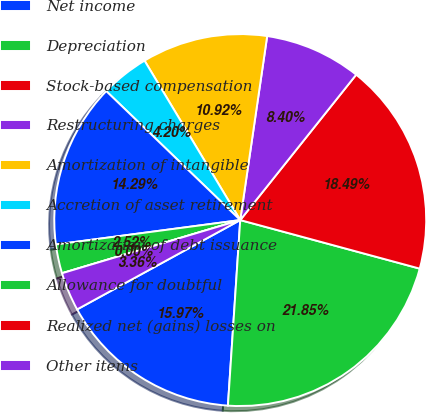<chart> <loc_0><loc_0><loc_500><loc_500><pie_chart><fcel>Net income<fcel>Depreciation<fcel>Stock-based compensation<fcel>Restructuring charges<fcel>Amortization of intangible<fcel>Accretion of asset retirement<fcel>Amortization of debt issuance<fcel>Allowance for doubtful<fcel>Realized net (gains) losses on<fcel>Other items<nl><fcel>15.97%<fcel>21.85%<fcel>18.49%<fcel>8.4%<fcel>10.92%<fcel>4.2%<fcel>14.29%<fcel>2.52%<fcel>0.0%<fcel>3.36%<nl></chart> 